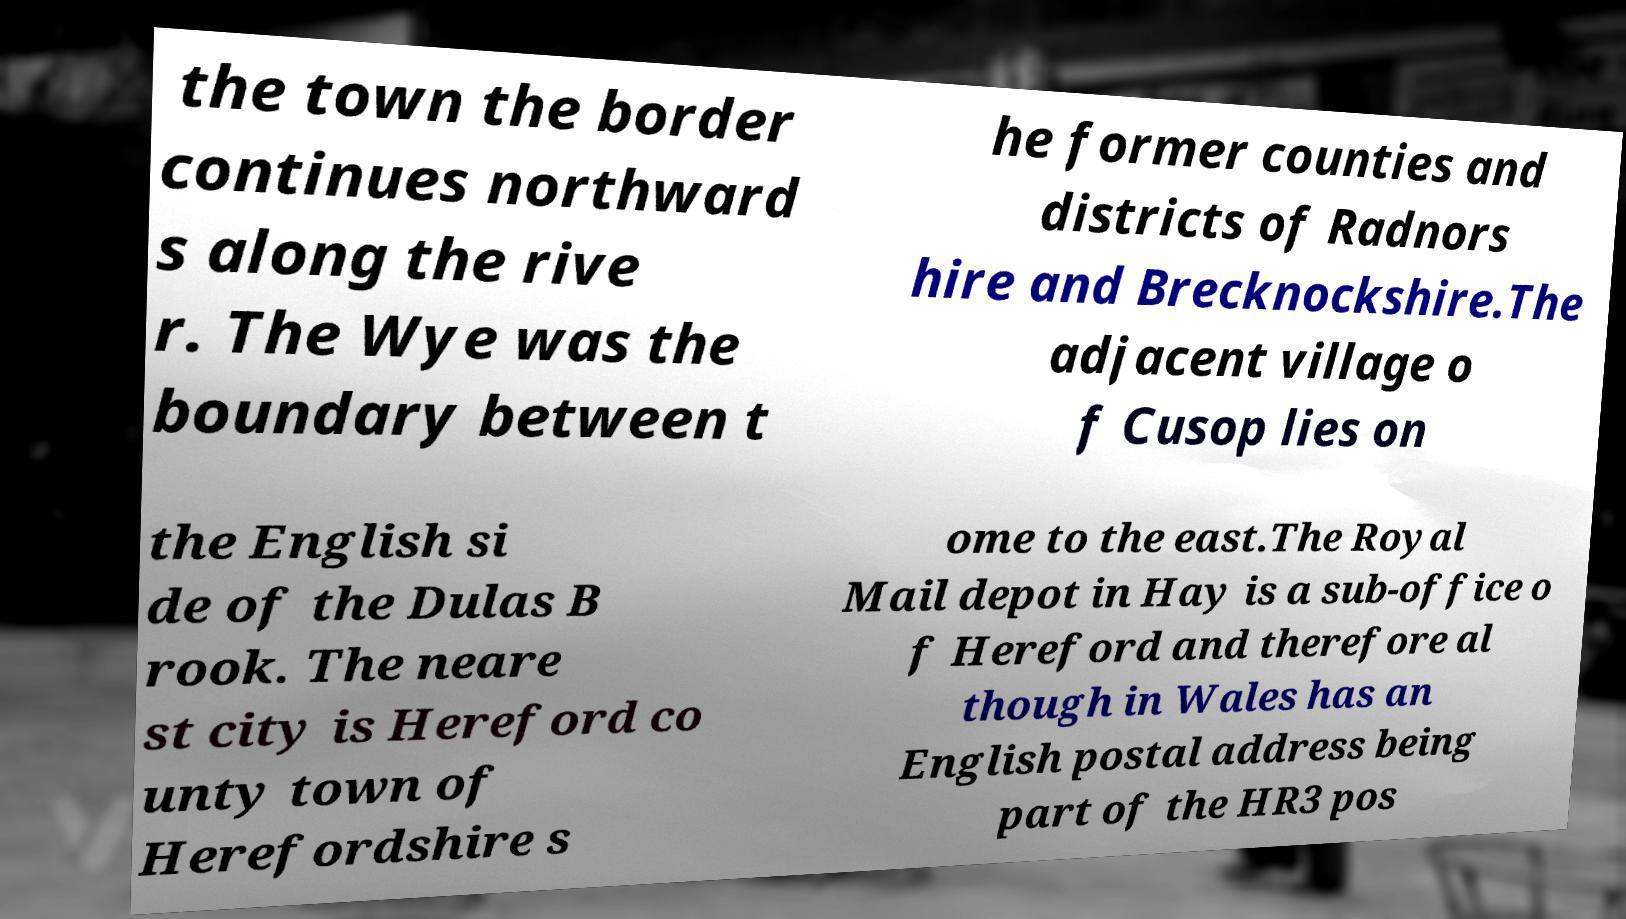What messages or text are displayed in this image? I need them in a readable, typed format. the town the border continues northward s along the rive r. The Wye was the boundary between t he former counties and districts of Radnors hire and Brecknockshire.The adjacent village o f Cusop lies on the English si de of the Dulas B rook. The neare st city is Hereford co unty town of Herefordshire s ome to the east.The Royal Mail depot in Hay is a sub-office o f Hereford and therefore al though in Wales has an English postal address being part of the HR3 pos 